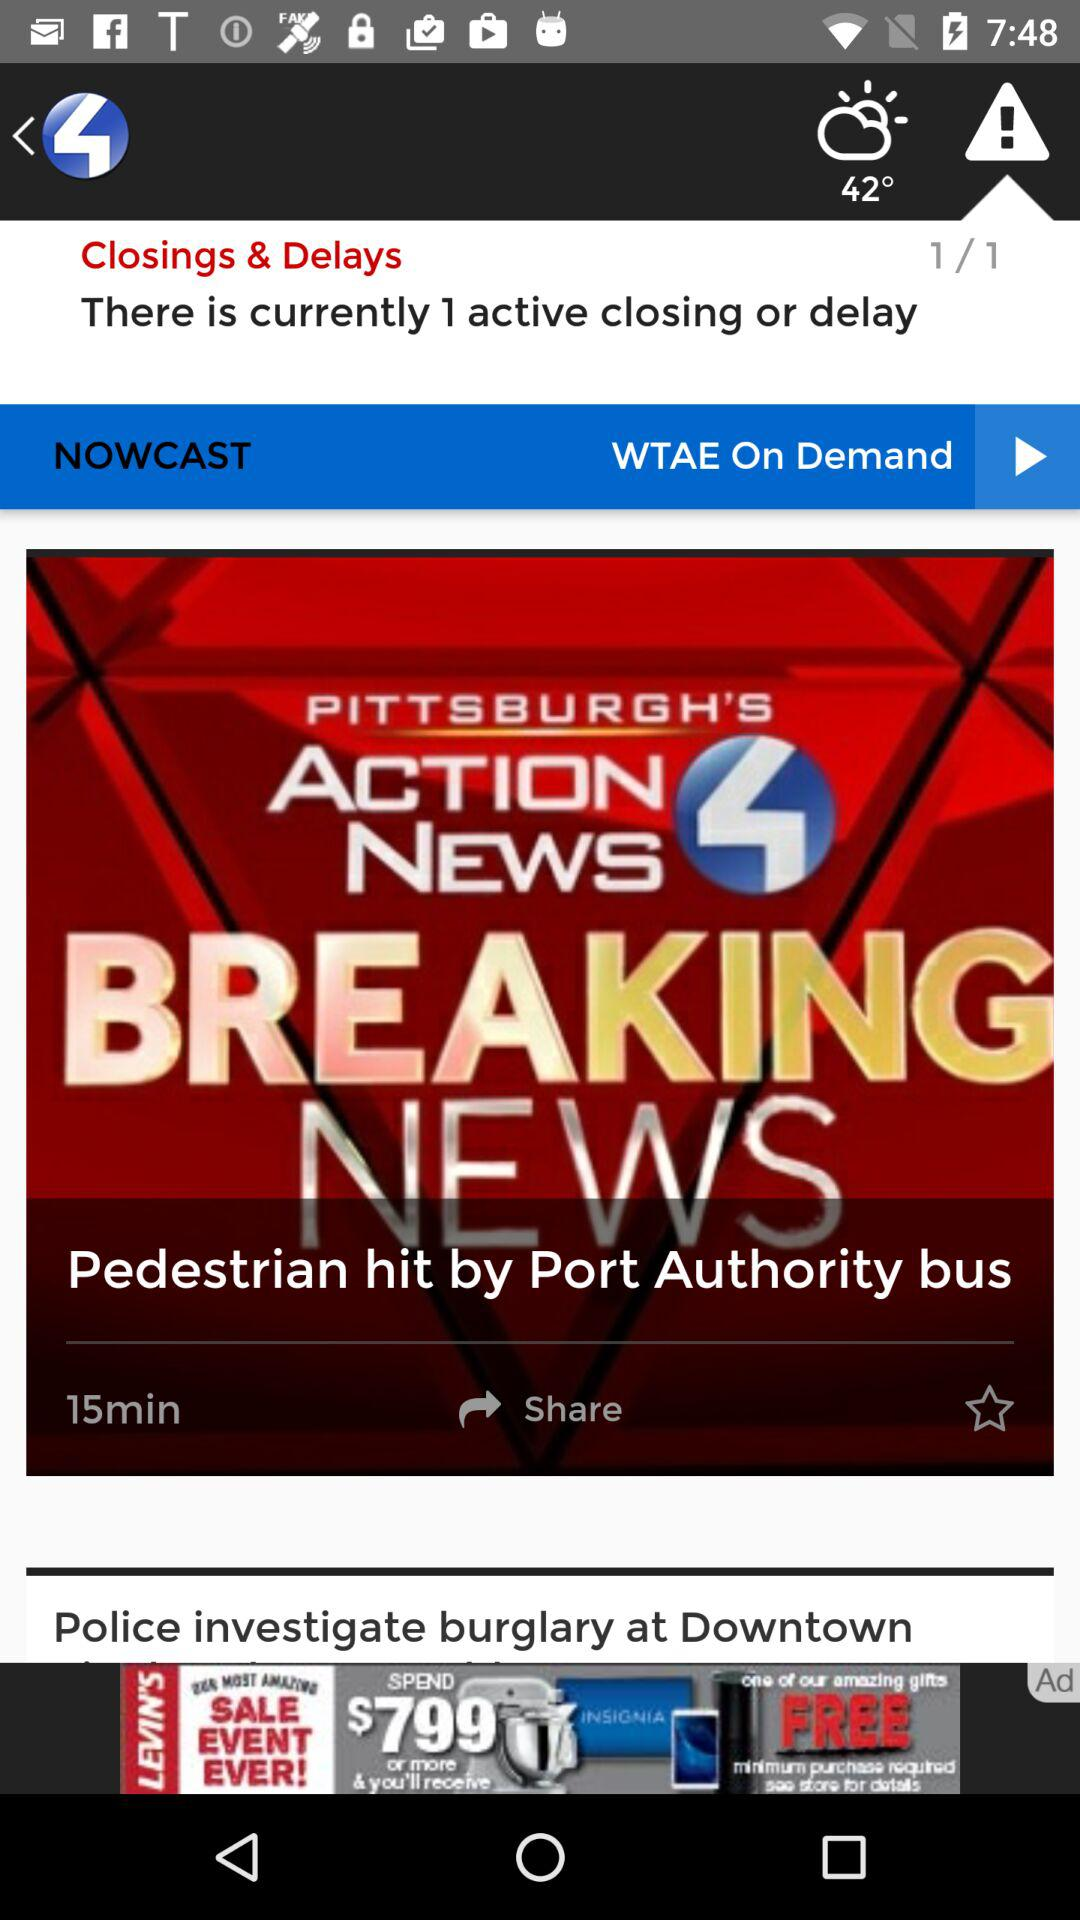What is the given temperature? The given temperature is 42 degrees. 